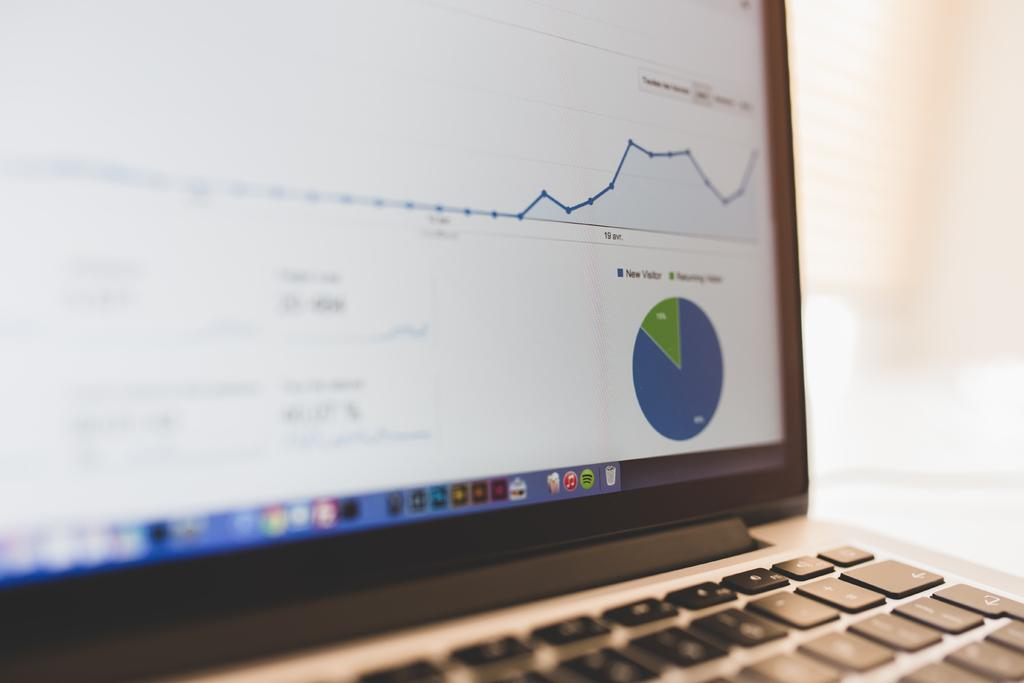<image>
Give a short and clear explanation of the subsequent image. Computer laptop screen showing a graph and the words "New Visitor" above it. 